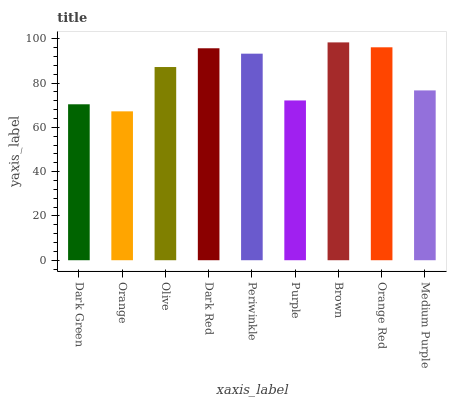Is Olive the minimum?
Answer yes or no. No. Is Olive the maximum?
Answer yes or no. No. Is Olive greater than Orange?
Answer yes or no. Yes. Is Orange less than Olive?
Answer yes or no. Yes. Is Orange greater than Olive?
Answer yes or no. No. Is Olive less than Orange?
Answer yes or no. No. Is Olive the high median?
Answer yes or no. Yes. Is Olive the low median?
Answer yes or no. Yes. Is Purple the high median?
Answer yes or no. No. Is Periwinkle the low median?
Answer yes or no. No. 